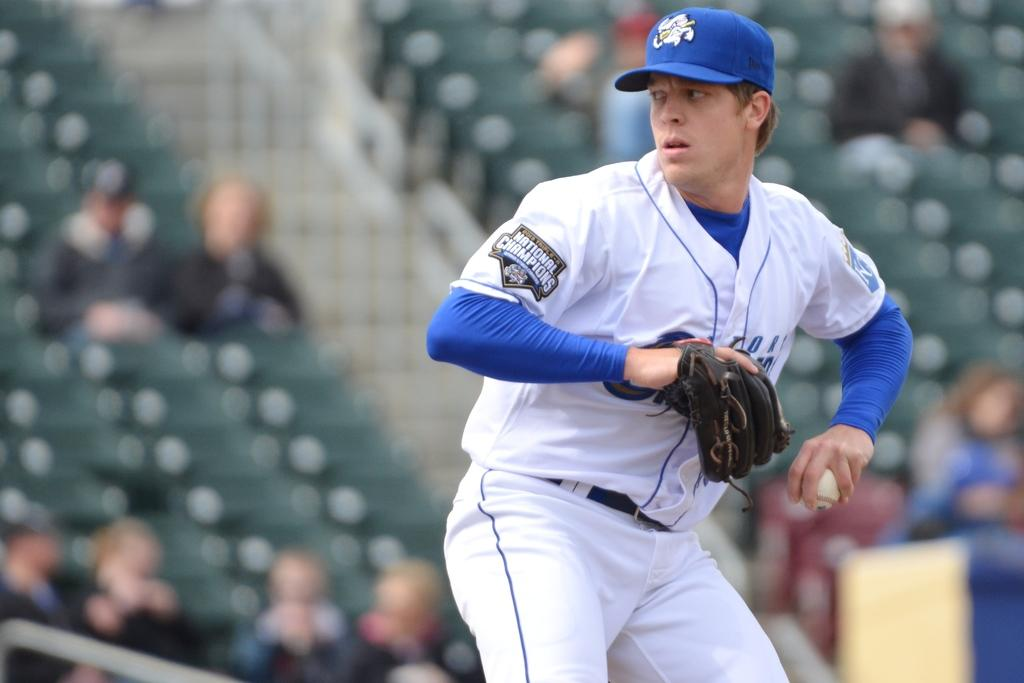Who is present in the image? There is a man in the image. What is the man wearing on his head? The man is wearing a cap. What else is the man wearing on his hand? The man is wearing a glove. Can you describe the background of the image? The background of the image is blurred. Are there any other people visible in the image? Yes, there are people visible in the image. What type of grass can be seen growing near the harbor in the image? There is no grass or harbor present in the image. Are there any police officers visible in the image? There is no mention of police officers in the provided facts, so we cannot determine if they are present in the image. 